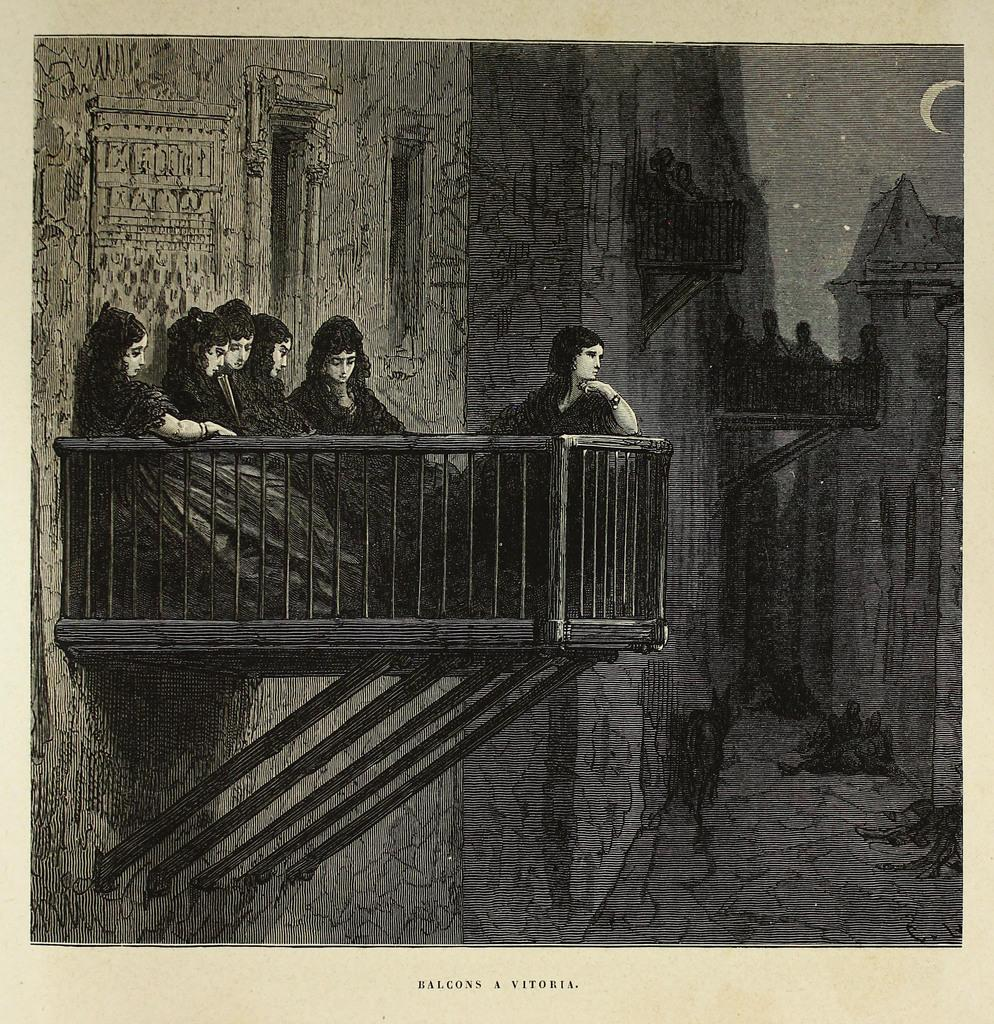What is the color scheme of the image? The image is black and white. Where are the women located in the image? The women are on the left side of the image. What celestial objects are present in the image? There are stars and a moon in the image. What type of lipstick is the woman wearing in the image? There is no lipstick or any indication of color in the black and white image. Can you describe the necklace the woman is wearing in the image? There is no necklace or any jewelry visible in the image. 